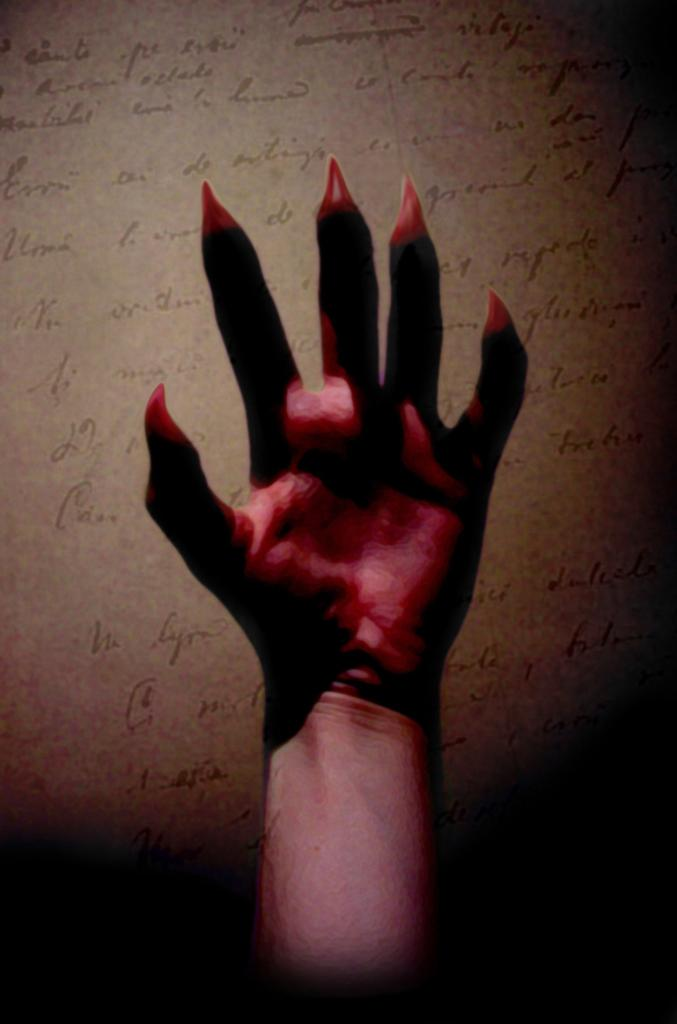What part of a person is visible in the image? There is a hand of a person in the image. Where is the hand located in the image? The hand is in the middle of the image. What else can be seen in the background of the image? There is text on a paper in the background of the image. What type of humor can be seen in the cave in the image? There is no cave present in the image, and therefore no humor can be observed in relation to a cave. 